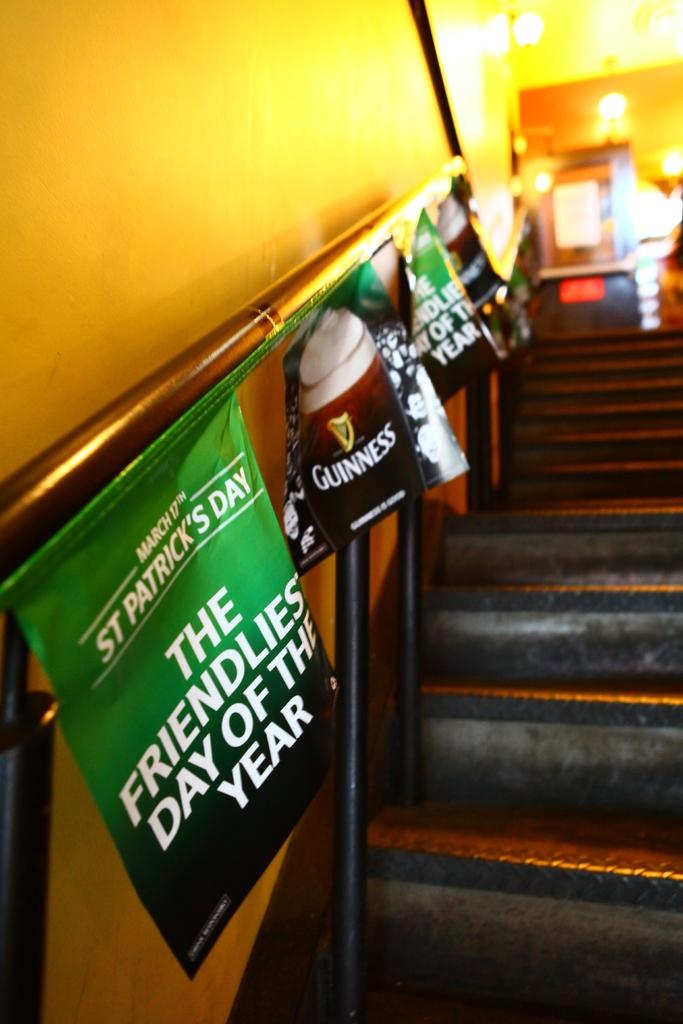<image>
Create a compact narrative representing the image presented. A Poster initmiating that St Patrick's Day is the friendliest day of the year. 